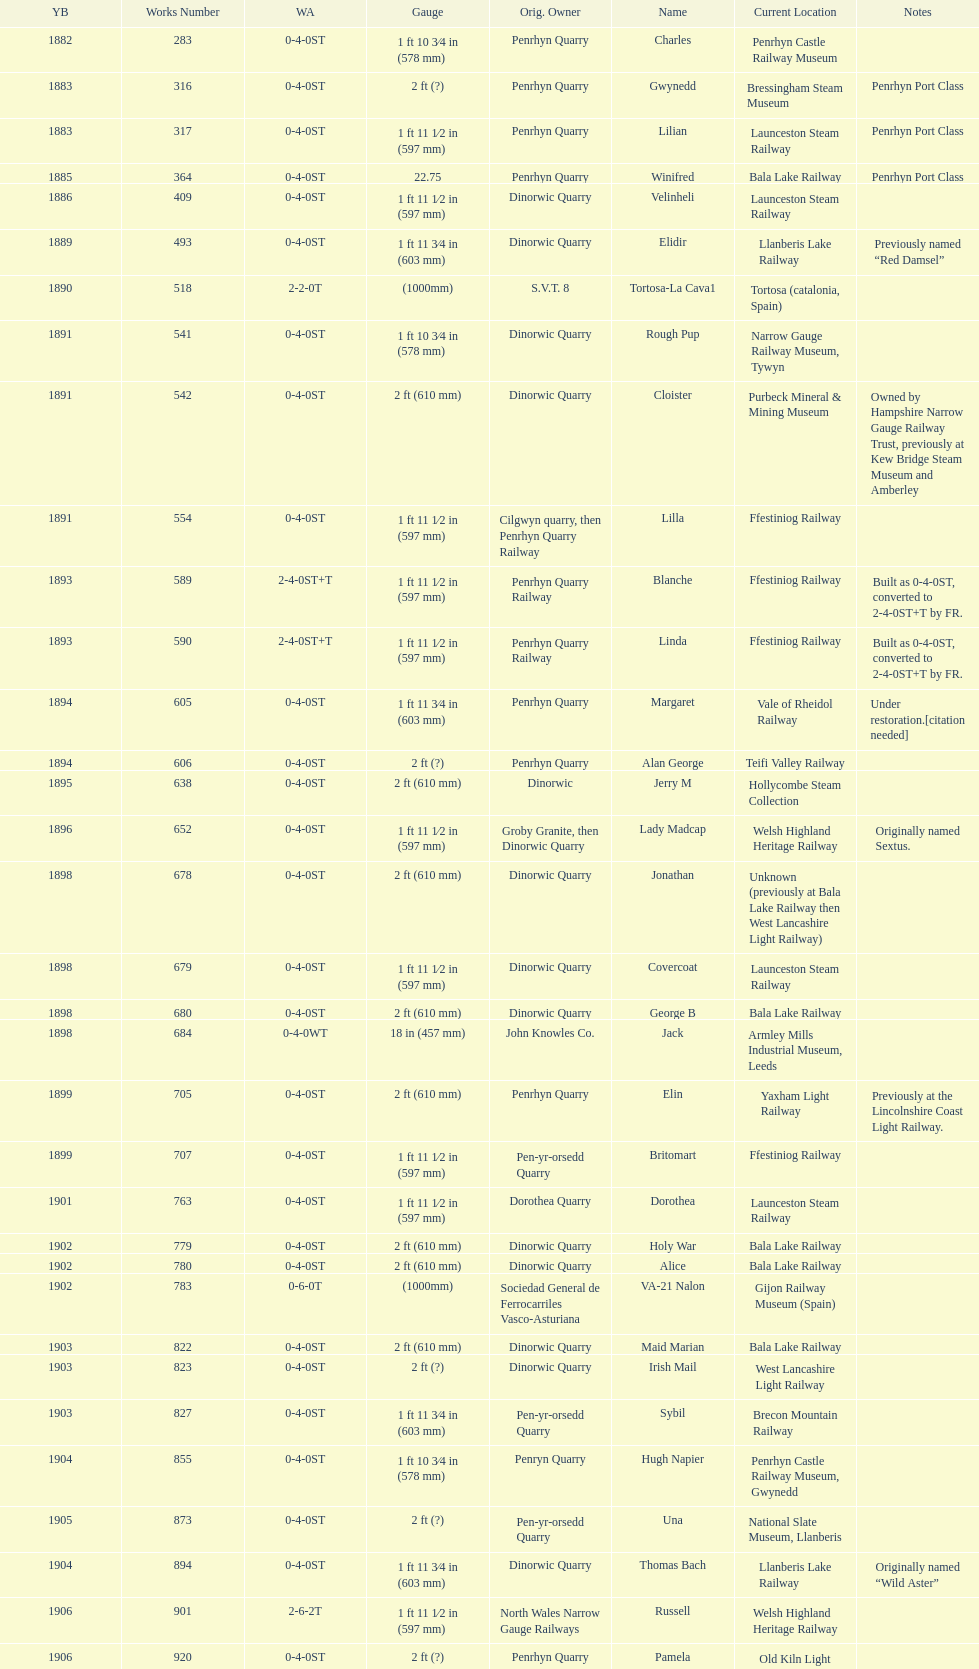In what way does the gauge vary between works numbers 541 and 542? 32 mm. 